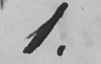Transcribe the text shown in this historical manuscript line. 1 . 